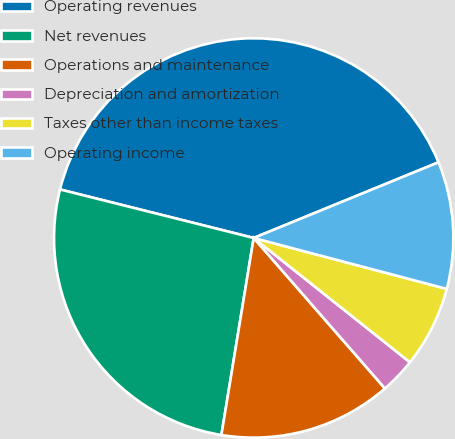Convert chart to OTSL. <chart><loc_0><loc_0><loc_500><loc_500><pie_chart><fcel>Operating revenues<fcel>Net revenues<fcel>Operations and maintenance<fcel>Depreciation and amortization<fcel>Taxes other than income taxes<fcel>Operating income<nl><fcel>39.91%<fcel>26.32%<fcel>14.0%<fcel>2.89%<fcel>6.59%<fcel>10.29%<nl></chart> 